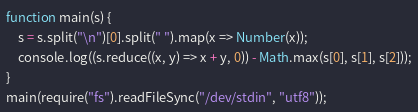Convert code to text. <code><loc_0><loc_0><loc_500><loc_500><_JavaScript_>function main(s) {
	s = s.split("\n")[0].split(" ").map(x => Number(x));
	console.log((s.reduce((x, y) => x + y, 0)) - Math.max(s[0], s[1], s[2]));
}
main(require("fs").readFileSync("/dev/stdin", "utf8"));

</code> 